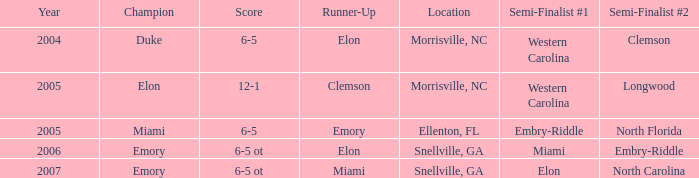Which team was the second semi finalist in 2007? North Carolina. 